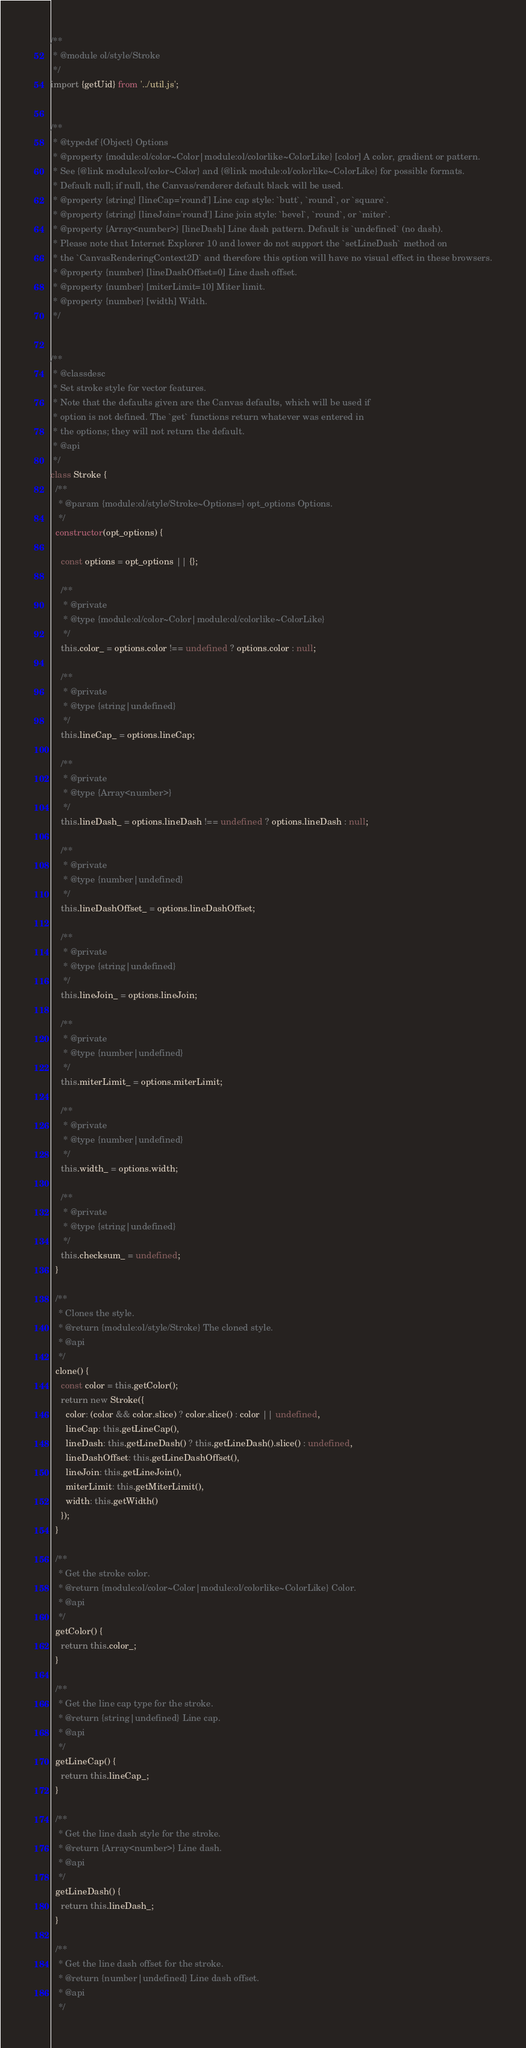Convert code to text. <code><loc_0><loc_0><loc_500><loc_500><_JavaScript_>/**
 * @module ol/style/Stroke
 */
import {getUid} from '../util.js';


/**
 * @typedef {Object} Options
 * @property {module:ol/color~Color|module:ol/colorlike~ColorLike} [color] A color, gradient or pattern.
 * See {@link module:ol/color~Color} and {@link module:ol/colorlike~ColorLike} for possible formats.
 * Default null; if null, the Canvas/renderer default black will be used.
 * @property {string} [lineCap='round'] Line cap style: `butt`, `round`, or `square`.
 * @property {string} [lineJoin='round'] Line join style: `bevel`, `round`, or `miter`.
 * @property {Array<number>} [lineDash] Line dash pattern. Default is `undefined` (no dash).
 * Please note that Internet Explorer 10 and lower do not support the `setLineDash` method on
 * the `CanvasRenderingContext2D` and therefore this option will have no visual effect in these browsers.
 * @property {number} [lineDashOffset=0] Line dash offset.
 * @property {number} [miterLimit=10] Miter limit.
 * @property {number} [width] Width.
 */


/**
 * @classdesc
 * Set stroke style for vector features.
 * Note that the defaults given are the Canvas defaults, which will be used if
 * option is not defined. The `get` functions return whatever was entered in
 * the options; they will not return the default.
 * @api
 */
class Stroke {
  /**
   * @param {module:ol/style/Stroke~Options=} opt_options Options.
   */
  constructor(opt_options) {

    const options = opt_options || {};

    /**
     * @private
     * @type {module:ol/color~Color|module:ol/colorlike~ColorLike}
     */
    this.color_ = options.color !== undefined ? options.color : null;

    /**
     * @private
     * @type {string|undefined}
     */
    this.lineCap_ = options.lineCap;

    /**
     * @private
     * @type {Array<number>}
     */
    this.lineDash_ = options.lineDash !== undefined ? options.lineDash : null;

    /**
     * @private
     * @type {number|undefined}
     */
    this.lineDashOffset_ = options.lineDashOffset;

    /**
     * @private
     * @type {string|undefined}
     */
    this.lineJoin_ = options.lineJoin;

    /**
     * @private
     * @type {number|undefined}
     */
    this.miterLimit_ = options.miterLimit;

    /**
     * @private
     * @type {number|undefined}
     */
    this.width_ = options.width;

    /**
     * @private
     * @type {string|undefined}
     */
    this.checksum_ = undefined;
  }

  /**
   * Clones the style.
   * @return {module:ol/style/Stroke} The cloned style.
   * @api
   */
  clone() {
    const color = this.getColor();
    return new Stroke({
      color: (color && color.slice) ? color.slice() : color || undefined,
      lineCap: this.getLineCap(),
      lineDash: this.getLineDash() ? this.getLineDash().slice() : undefined,
      lineDashOffset: this.getLineDashOffset(),
      lineJoin: this.getLineJoin(),
      miterLimit: this.getMiterLimit(),
      width: this.getWidth()
    });
  }

  /**
   * Get the stroke color.
   * @return {module:ol/color~Color|module:ol/colorlike~ColorLike} Color.
   * @api
   */
  getColor() {
    return this.color_;
  }

  /**
   * Get the line cap type for the stroke.
   * @return {string|undefined} Line cap.
   * @api
   */
  getLineCap() {
    return this.lineCap_;
  }

  /**
   * Get the line dash style for the stroke.
   * @return {Array<number>} Line dash.
   * @api
   */
  getLineDash() {
    return this.lineDash_;
  }

  /**
   * Get the line dash offset for the stroke.
   * @return {number|undefined} Line dash offset.
   * @api
   */</code> 